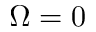<formula> <loc_0><loc_0><loc_500><loc_500>\Omega = 0</formula> 